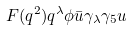Convert formula to latex. <formula><loc_0><loc_0><loc_500><loc_500>F ( q ^ { 2 } ) q ^ { \lambda } \phi \bar { u } \gamma _ { \lambda } \gamma _ { 5 } u</formula> 